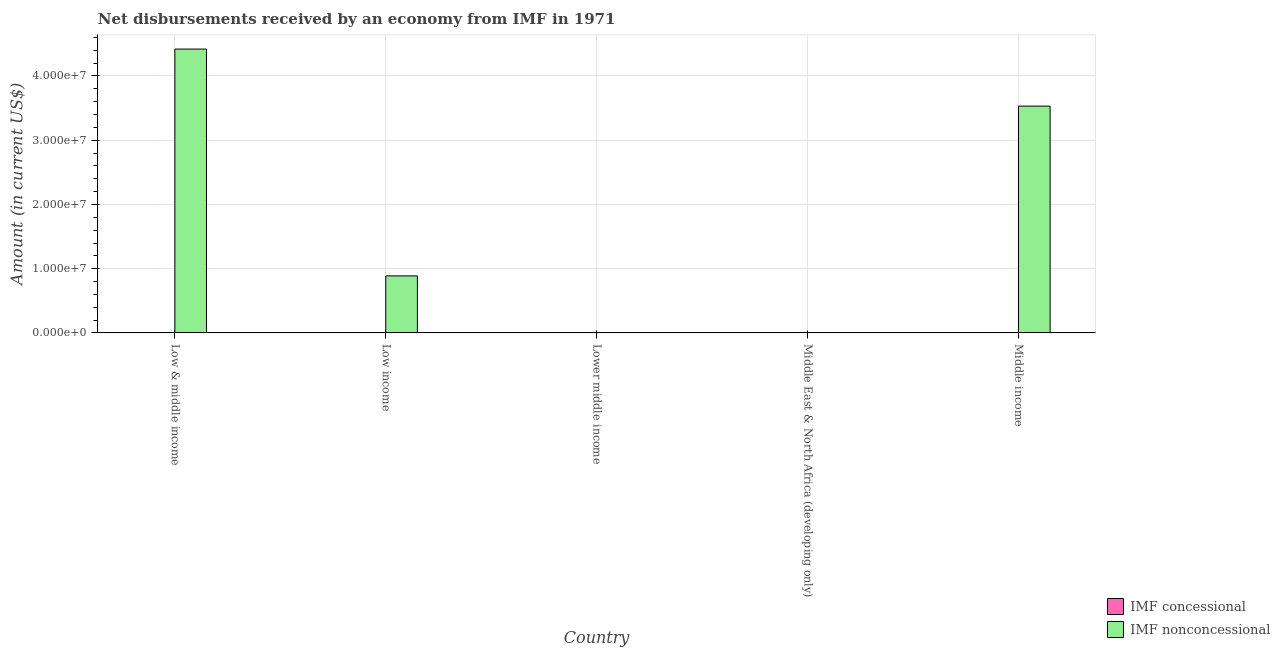Are the number of bars per tick equal to the number of legend labels?
Offer a very short reply. No. Are the number of bars on each tick of the X-axis equal?
Ensure brevity in your answer.  No. How many bars are there on the 3rd tick from the right?
Provide a succinct answer. 0. In how many cases, is the number of bars for a given country not equal to the number of legend labels?
Your answer should be compact. 5. What is the net concessional disbursements from imf in Middle East & North Africa (developing only)?
Provide a short and direct response. 0. Across all countries, what is the maximum net non concessional disbursements from imf?
Ensure brevity in your answer.  4.42e+07. Across all countries, what is the minimum net concessional disbursements from imf?
Your answer should be very brief. 0. What is the total net non concessional disbursements from imf in the graph?
Make the answer very short. 8.84e+07. What is the difference between the net non concessional disbursements from imf in Low & middle income and that in Middle income?
Your answer should be compact. 8.88e+06. What is the difference between the net non concessional disbursements from imf in Low income and the net concessional disbursements from imf in Middle income?
Your answer should be very brief. 8.88e+06. What is the average net non concessional disbursements from imf per country?
Give a very brief answer. 1.77e+07. In how many countries, is the net concessional disbursements from imf greater than 20000000 US$?
Offer a very short reply. 0. What is the ratio of the net non concessional disbursements from imf in Low & middle income to that in Middle income?
Provide a succinct answer. 1.25. Is the net non concessional disbursements from imf in Low & middle income less than that in Low income?
Offer a very short reply. No. What is the difference between the highest and the second highest net non concessional disbursements from imf?
Offer a terse response. 8.88e+06. What is the difference between the highest and the lowest net non concessional disbursements from imf?
Your response must be concise. 4.42e+07. Is the sum of the net non concessional disbursements from imf in Low income and Middle income greater than the maximum net concessional disbursements from imf across all countries?
Your answer should be compact. Yes. Are all the bars in the graph horizontal?
Ensure brevity in your answer.  No. Are the values on the major ticks of Y-axis written in scientific E-notation?
Make the answer very short. Yes. Does the graph contain any zero values?
Offer a very short reply. Yes. Does the graph contain grids?
Your answer should be compact. Yes. Where does the legend appear in the graph?
Provide a short and direct response. Bottom right. How many legend labels are there?
Make the answer very short. 2. What is the title of the graph?
Keep it short and to the point. Net disbursements received by an economy from IMF in 1971. What is the label or title of the X-axis?
Provide a succinct answer. Country. What is the Amount (in current US$) of IMF concessional in Low & middle income?
Your response must be concise. 0. What is the Amount (in current US$) of IMF nonconcessional in Low & middle income?
Keep it short and to the point. 4.42e+07. What is the Amount (in current US$) of IMF concessional in Low income?
Your answer should be compact. 0. What is the Amount (in current US$) in IMF nonconcessional in Low income?
Provide a succinct answer. 8.88e+06. What is the Amount (in current US$) in IMF concessional in Lower middle income?
Offer a terse response. 0. What is the Amount (in current US$) in IMF concessional in Middle East & North Africa (developing only)?
Your response must be concise. 0. What is the Amount (in current US$) of IMF nonconcessional in Middle East & North Africa (developing only)?
Make the answer very short. 0. What is the Amount (in current US$) in IMF concessional in Middle income?
Your response must be concise. 0. What is the Amount (in current US$) in IMF nonconcessional in Middle income?
Offer a very short reply. 3.53e+07. Across all countries, what is the maximum Amount (in current US$) in IMF nonconcessional?
Provide a succinct answer. 4.42e+07. Across all countries, what is the minimum Amount (in current US$) of IMF nonconcessional?
Give a very brief answer. 0. What is the total Amount (in current US$) of IMF concessional in the graph?
Offer a very short reply. 0. What is the total Amount (in current US$) in IMF nonconcessional in the graph?
Offer a very short reply. 8.84e+07. What is the difference between the Amount (in current US$) in IMF nonconcessional in Low & middle income and that in Low income?
Give a very brief answer. 3.53e+07. What is the difference between the Amount (in current US$) in IMF nonconcessional in Low & middle income and that in Middle income?
Keep it short and to the point. 8.88e+06. What is the difference between the Amount (in current US$) of IMF nonconcessional in Low income and that in Middle income?
Provide a succinct answer. -2.64e+07. What is the average Amount (in current US$) in IMF nonconcessional per country?
Ensure brevity in your answer.  1.77e+07. What is the ratio of the Amount (in current US$) of IMF nonconcessional in Low & middle income to that in Low income?
Your answer should be very brief. 4.98. What is the ratio of the Amount (in current US$) of IMF nonconcessional in Low & middle income to that in Middle income?
Offer a very short reply. 1.25. What is the ratio of the Amount (in current US$) of IMF nonconcessional in Low income to that in Middle income?
Provide a short and direct response. 0.25. What is the difference between the highest and the second highest Amount (in current US$) in IMF nonconcessional?
Your answer should be compact. 8.88e+06. What is the difference between the highest and the lowest Amount (in current US$) in IMF nonconcessional?
Your answer should be very brief. 4.42e+07. 